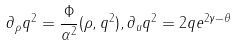Convert formula to latex. <formula><loc_0><loc_0><loc_500><loc_500>\partial _ { \rho } q ^ { 2 } = \frac { \Phi } { \alpha ^ { 2 } } ( \rho , q ^ { 2 } ) , \partial _ { u } q ^ { 2 } = 2 q e ^ { 2 \gamma - \theta }</formula> 